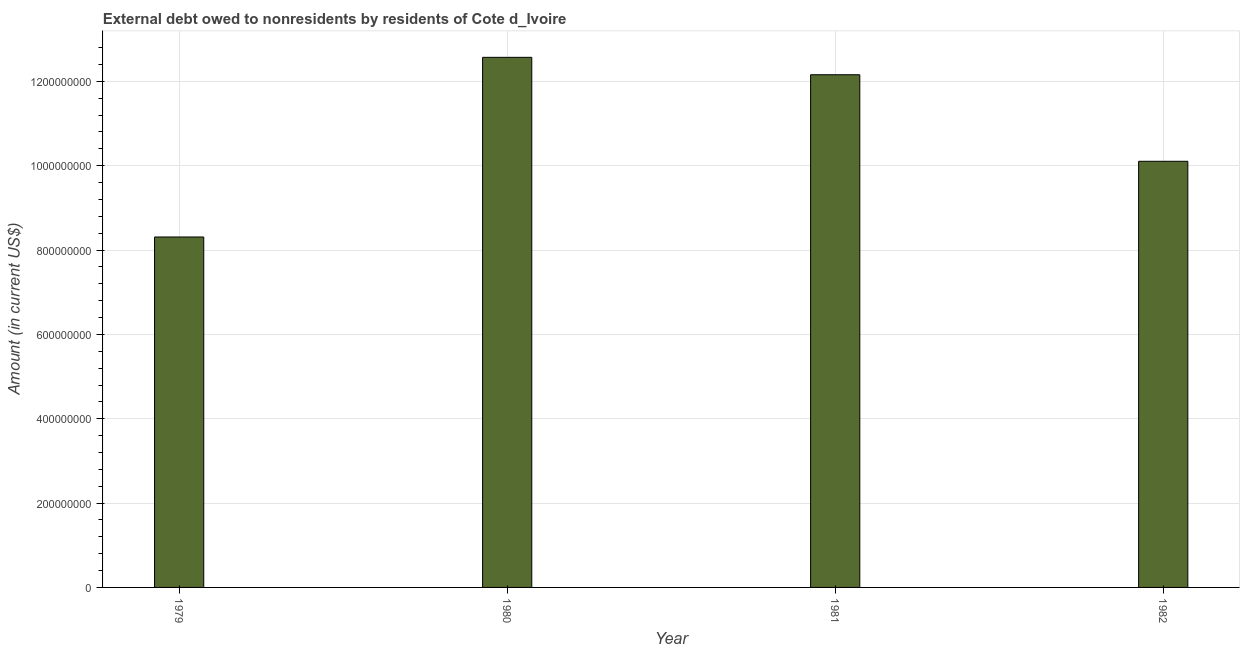What is the title of the graph?
Provide a short and direct response. External debt owed to nonresidents by residents of Cote d_Ivoire. What is the label or title of the X-axis?
Provide a succinct answer. Year. What is the debt in 1981?
Keep it short and to the point. 1.22e+09. Across all years, what is the maximum debt?
Your answer should be compact. 1.26e+09. Across all years, what is the minimum debt?
Your answer should be compact. 8.31e+08. In which year was the debt minimum?
Provide a succinct answer. 1979. What is the sum of the debt?
Offer a very short reply. 4.31e+09. What is the difference between the debt in 1979 and 1981?
Give a very brief answer. -3.85e+08. What is the average debt per year?
Your answer should be compact. 1.08e+09. What is the median debt?
Provide a short and direct response. 1.11e+09. In how many years, is the debt greater than 200000000 US$?
Provide a succinct answer. 4. What is the ratio of the debt in 1980 to that in 1981?
Make the answer very short. 1.03. Is the debt in 1979 less than that in 1982?
Give a very brief answer. Yes. Is the difference between the debt in 1979 and 1980 greater than the difference between any two years?
Offer a very short reply. Yes. What is the difference between the highest and the second highest debt?
Your answer should be compact. 4.13e+07. What is the difference between the highest and the lowest debt?
Your answer should be very brief. 4.26e+08. How many years are there in the graph?
Ensure brevity in your answer.  4. What is the difference between two consecutive major ticks on the Y-axis?
Your answer should be very brief. 2.00e+08. What is the Amount (in current US$) of 1979?
Your answer should be very brief. 8.31e+08. What is the Amount (in current US$) in 1980?
Provide a succinct answer. 1.26e+09. What is the Amount (in current US$) in 1981?
Offer a terse response. 1.22e+09. What is the Amount (in current US$) of 1982?
Your response must be concise. 1.01e+09. What is the difference between the Amount (in current US$) in 1979 and 1980?
Offer a very short reply. -4.26e+08. What is the difference between the Amount (in current US$) in 1979 and 1981?
Provide a short and direct response. -3.85e+08. What is the difference between the Amount (in current US$) in 1979 and 1982?
Give a very brief answer. -1.79e+08. What is the difference between the Amount (in current US$) in 1980 and 1981?
Your answer should be compact. 4.13e+07. What is the difference between the Amount (in current US$) in 1980 and 1982?
Offer a very short reply. 2.47e+08. What is the difference between the Amount (in current US$) in 1981 and 1982?
Offer a terse response. 2.05e+08. What is the ratio of the Amount (in current US$) in 1979 to that in 1980?
Provide a succinct answer. 0.66. What is the ratio of the Amount (in current US$) in 1979 to that in 1981?
Your answer should be very brief. 0.68. What is the ratio of the Amount (in current US$) in 1979 to that in 1982?
Ensure brevity in your answer.  0.82. What is the ratio of the Amount (in current US$) in 1980 to that in 1981?
Your answer should be compact. 1.03. What is the ratio of the Amount (in current US$) in 1980 to that in 1982?
Provide a short and direct response. 1.24. What is the ratio of the Amount (in current US$) in 1981 to that in 1982?
Offer a terse response. 1.2. 